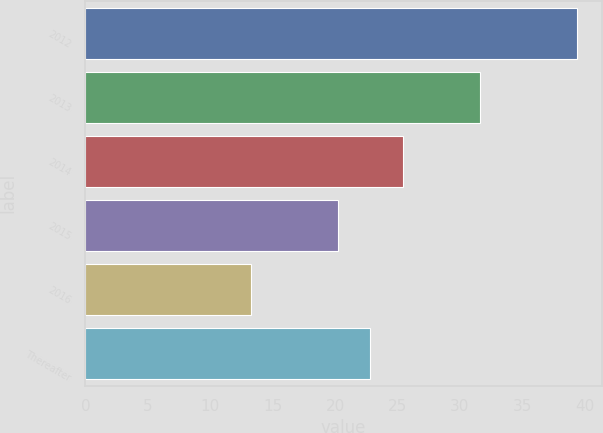Convert chart to OTSL. <chart><loc_0><loc_0><loc_500><loc_500><bar_chart><fcel>2012<fcel>2013<fcel>2014<fcel>2015<fcel>2016<fcel>Thereafter<nl><fcel>39.4<fcel>31.6<fcel>25.42<fcel>20.2<fcel>13.3<fcel>22.81<nl></chart> 